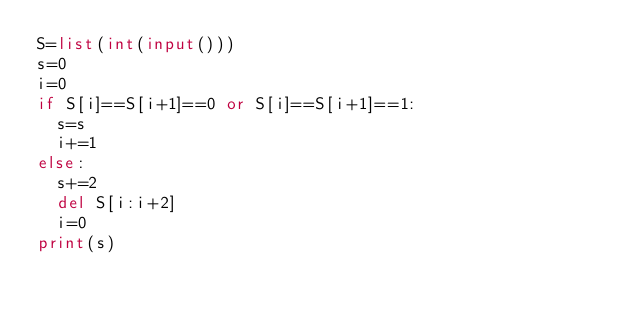<code> <loc_0><loc_0><loc_500><loc_500><_Python_>S=list(int(input()))
s=0
i=0
if S[i]==S[i+1]==0 or S[i]==S[i+1]==1:
  s=s
  i+=1
else:
  s+=2
  del S[i:i+2]
  i=0
print(s)</code> 